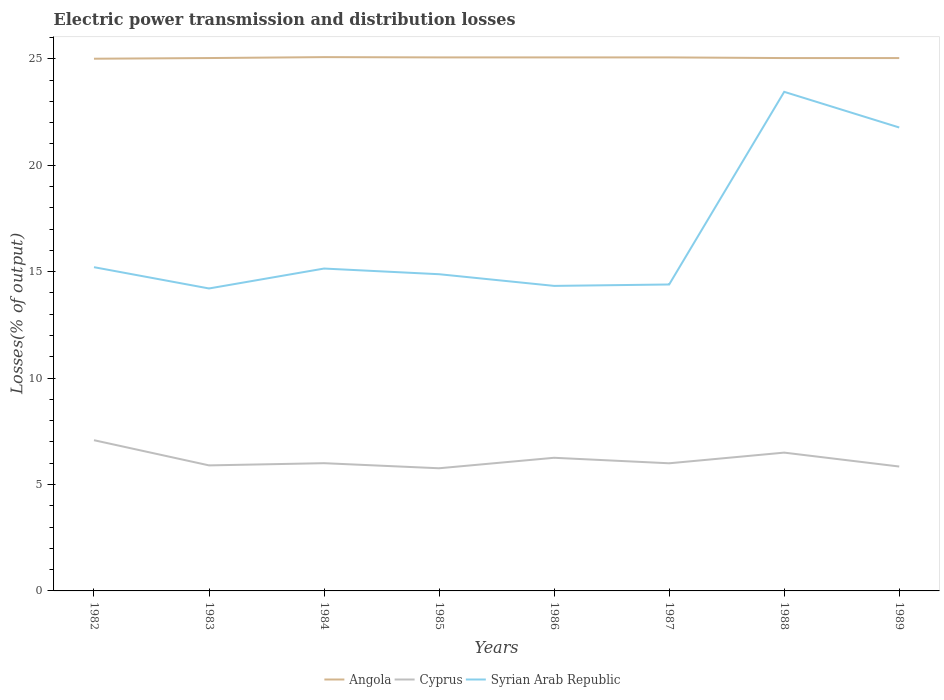How many different coloured lines are there?
Provide a short and direct response. 3. Across all years, what is the maximum electric power transmission and distribution losses in Cyprus?
Give a very brief answer. 5.76. In which year was the electric power transmission and distribution losses in Cyprus maximum?
Your answer should be very brief. 1985. What is the total electric power transmission and distribution losses in Cyprus in the graph?
Your answer should be very brief. -0.73. What is the difference between the highest and the second highest electric power transmission and distribution losses in Syrian Arab Republic?
Your response must be concise. 9.24. Is the electric power transmission and distribution losses in Syrian Arab Republic strictly greater than the electric power transmission and distribution losses in Angola over the years?
Keep it short and to the point. Yes. How many lines are there?
Ensure brevity in your answer.  3. How many years are there in the graph?
Offer a terse response. 8. What is the difference between two consecutive major ticks on the Y-axis?
Ensure brevity in your answer.  5. Are the values on the major ticks of Y-axis written in scientific E-notation?
Keep it short and to the point. No. Does the graph contain any zero values?
Your response must be concise. No. How many legend labels are there?
Make the answer very short. 3. What is the title of the graph?
Your answer should be very brief. Electric power transmission and distribution losses. What is the label or title of the X-axis?
Provide a succinct answer. Years. What is the label or title of the Y-axis?
Offer a very short reply. Losses(% of output). What is the Losses(% of output) in Cyprus in 1982?
Your answer should be compact. 7.08. What is the Losses(% of output) of Syrian Arab Republic in 1982?
Make the answer very short. 15.21. What is the Losses(% of output) of Angola in 1983?
Make the answer very short. 25.03. What is the Losses(% of output) of Cyprus in 1983?
Offer a terse response. 5.9. What is the Losses(% of output) in Syrian Arab Republic in 1983?
Offer a very short reply. 14.21. What is the Losses(% of output) of Angola in 1984?
Make the answer very short. 25.07. What is the Losses(% of output) in Syrian Arab Republic in 1984?
Your answer should be compact. 15.14. What is the Losses(% of output) of Angola in 1985?
Offer a very short reply. 25.06. What is the Losses(% of output) in Cyprus in 1985?
Offer a terse response. 5.76. What is the Losses(% of output) in Syrian Arab Republic in 1985?
Ensure brevity in your answer.  14.88. What is the Losses(% of output) of Angola in 1986?
Your answer should be very brief. 25.06. What is the Losses(% of output) of Cyprus in 1986?
Offer a terse response. 6.25. What is the Losses(% of output) in Syrian Arab Republic in 1986?
Your answer should be very brief. 14.33. What is the Losses(% of output) of Angola in 1987?
Give a very brief answer. 25.06. What is the Losses(% of output) in Cyprus in 1987?
Provide a short and direct response. 6. What is the Losses(% of output) in Syrian Arab Republic in 1987?
Ensure brevity in your answer.  14.39. What is the Losses(% of output) in Angola in 1988?
Keep it short and to the point. 25.03. What is the Losses(% of output) in Cyprus in 1988?
Make the answer very short. 6.5. What is the Losses(% of output) in Syrian Arab Republic in 1988?
Your answer should be compact. 23.44. What is the Losses(% of output) of Angola in 1989?
Provide a succinct answer. 25.03. What is the Losses(% of output) of Cyprus in 1989?
Provide a succinct answer. 5.84. What is the Losses(% of output) of Syrian Arab Republic in 1989?
Offer a very short reply. 21.77. Across all years, what is the maximum Losses(% of output) of Angola?
Provide a short and direct response. 25.07. Across all years, what is the maximum Losses(% of output) in Cyprus?
Ensure brevity in your answer.  7.08. Across all years, what is the maximum Losses(% of output) of Syrian Arab Republic?
Offer a very short reply. 23.44. Across all years, what is the minimum Losses(% of output) of Angola?
Offer a terse response. 25. Across all years, what is the minimum Losses(% of output) of Cyprus?
Your answer should be compact. 5.76. Across all years, what is the minimum Losses(% of output) of Syrian Arab Republic?
Ensure brevity in your answer.  14.21. What is the total Losses(% of output) in Angola in the graph?
Give a very brief answer. 200.35. What is the total Losses(% of output) in Cyprus in the graph?
Keep it short and to the point. 49.33. What is the total Losses(% of output) in Syrian Arab Republic in the graph?
Offer a very short reply. 133.37. What is the difference between the Losses(% of output) of Angola in 1982 and that in 1983?
Your answer should be very brief. -0.03. What is the difference between the Losses(% of output) of Cyprus in 1982 and that in 1983?
Make the answer very short. 1.18. What is the difference between the Losses(% of output) in Syrian Arab Republic in 1982 and that in 1983?
Provide a short and direct response. 1. What is the difference between the Losses(% of output) in Angola in 1982 and that in 1984?
Make the answer very short. -0.07. What is the difference between the Losses(% of output) in Cyprus in 1982 and that in 1984?
Ensure brevity in your answer.  1.08. What is the difference between the Losses(% of output) in Syrian Arab Republic in 1982 and that in 1984?
Provide a short and direct response. 0.06. What is the difference between the Losses(% of output) in Angola in 1982 and that in 1985?
Your answer should be compact. -0.06. What is the difference between the Losses(% of output) in Cyprus in 1982 and that in 1985?
Provide a short and direct response. 1.32. What is the difference between the Losses(% of output) in Syrian Arab Republic in 1982 and that in 1985?
Provide a succinct answer. 0.33. What is the difference between the Losses(% of output) of Angola in 1982 and that in 1986?
Give a very brief answer. -0.06. What is the difference between the Losses(% of output) of Cyprus in 1982 and that in 1986?
Your response must be concise. 0.83. What is the difference between the Losses(% of output) of Syrian Arab Republic in 1982 and that in 1986?
Offer a very short reply. 0.88. What is the difference between the Losses(% of output) of Angola in 1982 and that in 1987?
Provide a short and direct response. -0.06. What is the difference between the Losses(% of output) in Cyprus in 1982 and that in 1987?
Offer a terse response. 1.08. What is the difference between the Losses(% of output) in Syrian Arab Republic in 1982 and that in 1987?
Make the answer very short. 0.81. What is the difference between the Losses(% of output) in Angola in 1982 and that in 1988?
Your response must be concise. -0.03. What is the difference between the Losses(% of output) in Cyprus in 1982 and that in 1988?
Keep it short and to the point. 0.58. What is the difference between the Losses(% of output) in Syrian Arab Republic in 1982 and that in 1988?
Make the answer very short. -8.24. What is the difference between the Losses(% of output) of Angola in 1982 and that in 1989?
Provide a short and direct response. -0.03. What is the difference between the Losses(% of output) in Cyprus in 1982 and that in 1989?
Offer a very short reply. 1.24. What is the difference between the Losses(% of output) in Syrian Arab Republic in 1982 and that in 1989?
Make the answer very short. -6.56. What is the difference between the Losses(% of output) of Angola in 1983 and that in 1984?
Your answer should be very brief. -0.04. What is the difference between the Losses(% of output) in Cyprus in 1983 and that in 1984?
Provide a succinct answer. -0.1. What is the difference between the Losses(% of output) in Syrian Arab Republic in 1983 and that in 1984?
Offer a terse response. -0.94. What is the difference between the Losses(% of output) in Angola in 1983 and that in 1985?
Provide a succinct answer. -0.03. What is the difference between the Losses(% of output) in Cyprus in 1983 and that in 1985?
Provide a short and direct response. 0.13. What is the difference between the Losses(% of output) of Syrian Arab Republic in 1983 and that in 1985?
Ensure brevity in your answer.  -0.67. What is the difference between the Losses(% of output) of Angola in 1983 and that in 1986?
Give a very brief answer. -0.03. What is the difference between the Losses(% of output) of Cyprus in 1983 and that in 1986?
Offer a very short reply. -0.36. What is the difference between the Losses(% of output) of Syrian Arab Republic in 1983 and that in 1986?
Your response must be concise. -0.12. What is the difference between the Losses(% of output) in Angola in 1983 and that in 1987?
Offer a terse response. -0.03. What is the difference between the Losses(% of output) in Cyprus in 1983 and that in 1987?
Offer a very short reply. -0.1. What is the difference between the Losses(% of output) in Syrian Arab Republic in 1983 and that in 1987?
Keep it short and to the point. -0.19. What is the difference between the Losses(% of output) of Angola in 1983 and that in 1988?
Provide a short and direct response. 0. What is the difference between the Losses(% of output) in Cyprus in 1983 and that in 1988?
Provide a short and direct response. -0.6. What is the difference between the Losses(% of output) of Syrian Arab Republic in 1983 and that in 1988?
Your answer should be compact. -9.24. What is the difference between the Losses(% of output) in Angola in 1983 and that in 1989?
Provide a succinct answer. 0. What is the difference between the Losses(% of output) in Cyprus in 1983 and that in 1989?
Keep it short and to the point. 0.05. What is the difference between the Losses(% of output) of Syrian Arab Republic in 1983 and that in 1989?
Your response must be concise. -7.56. What is the difference between the Losses(% of output) of Angola in 1984 and that in 1985?
Provide a succinct answer. 0.01. What is the difference between the Losses(% of output) of Cyprus in 1984 and that in 1985?
Your answer should be compact. 0.24. What is the difference between the Losses(% of output) of Syrian Arab Republic in 1984 and that in 1985?
Give a very brief answer. 0.27. What is the difference between the Losses(% of output) of Angola in 1984 and that in 1986?
Your answer should be very brief. 0.01. What is the difference between the Losses(% of output) in Cyprus in 1984 and that in 1986?
Offer a terse response. -0.25. What is the difference between the Losses(% of output) in Syrian Arab Republic in 1984 and that in 1986?
Make the answer very short. 0.81. What is the difference between the Losses(% of output) in Angola in 1984 and that in 1987?
Provide a succinct answer. 0.01. What is the difference between the Losses(% of output) in Cyprus in 1984 and that in 1987?
Your answer should be compact. 0. What is the difference between the Losses(% of output) of Syrian Arab Republic in 1984 and that in 1987?
Your answer should be compact. 0.75. What is the difference between the Losses(% of output) in Angola in 1984 and that in 1988?
Give a very brief answer. 0.04. What is the difference between the Losses(% of output) of Cyprus in 1984 and that in 1988?
Keep it short and to the point. -0.5. What is the difference between the Losses(% of output) in Syrian Arab Republic in 1984 and that in 1988?
Your answer should be compact. -8.3. What is the difference between the Losses(% of output) of Angola in 1984 and that in 1989?
Provide a short and direct response. 0.04. What is the difference between the Losses(% of output) in Cyprus in 1984 and that in 1989?
Offer a terse response. 0.16. What is the difference between the Losses(% of output) of Syrian Arab Republic in 1984 and that in 1989?
Keep it short and to the point. -6.63. What is the difference between the Losses(% of output) in Cyprus in 1985 and that in 1986?
Your response must be concise. -0.49. What is the difference between the Losses(% of output) of Syrian Arab Republic in 1985 and that in 1986?
Your answer should be very brief. 0.55. What is the difference between the Losses(% of output) of Cyprus in 1985 and that in 1987?
Give a very brief answer. -0.23. What is the difference between the Losses(% of output) in Syrian Arab Republic in 1985 and that in 1987?
Your answer should be very brief. 0.48. What is the difference between the Losses(% of output) in Angola in 1985 and that in 1988?
Your response must be concise. 0.03. What is the difference between the Losses(% of output) of Cyprus in 1985 and that in 1988?
Ensure brevity in your answer.  -0.73. What is the difference between the Losses(% of output) in Syrian Arab Republic in 1985 and that in 1988?
Keep it short and to the point. -8.57. What is the difference between the Losses(% of output) in Angola in 1985 and that in 1989?
Your answer should be very brief. 0.03. What is the difference between the Losses(% of output) in Cyprus in 1985 and that in 1989?
Offer a terse response. -0.08. What is the difference between the Losses(% of output) in Syrian Arab Republic in 1985 and that in 1989?
Offer a terse response. -6.89. What is the difference between the Losses(% of output) of Cyprus in 1986 and that in 1987?
Offer a very short reply. 0.26. What is the difference between the Losses(% of output) of Syrian Arab Republic in 1986 and that in 1987?
Ensure brevity in your answer.  -0.07. What is the difference between the Losses(% of output) in Angola in 1986 and that in 1988?
Your answer should be compact. 0.03. What is the difference between the Losses(% of output) in Cyprus in 1986 and that in 1988?
Make the answer very short. -0.24. What is the difference between the Losses(% of output) in Syrian Arab Republic in 1986 and that in 1988?
Provide a succinct answer. -9.12. What is the difference between the Losses(% of output) in Angola in 1986 and that in 1989?
Make the answer very short. 0.03. What is the difference between the Losses(% of output) of Cyprus in 1986 and that in 1989?
Give a very brief answer. 0.41. What is the difference between the Losses(% of output) in Syrian Arab Republic in 1986 and that in 1989?
Ensure brevity in your answer.  -7.44. What is the difference between the Losses(% of output) in Angola in 1987 and that in 1988?
Ensure brevity in your answer.  0.03. What is the difference between the Losses(% of output) in Cyprus in 1987 and that in 1988?
Ensure brevity in your answer.  -0.5. What is the difference between the Losses(% of output) in Syrian Arab Republic in 1987 and that in 1988?
Keep it short and to the point. -9.05. What is the difference between the Losses(% of output) in Angola in 1987 and that in 1989?
Your answer should be very brief. 0.03. What is the difference between the Losses(% of output) of Cyprus in 1987 and that in 1989?
Offer a terse response. 0.15. What is the difference between the Losses(% of output) of Syrian Arab Republic in 1987 and that in 1989?
Make the answer very short. -7.37. What is the difference between the Losses(% of output) in Cyprus in 1988 and that in 1989?
Your answer should be very brief. 0.65. What is the difference between the Losses(% of output) of Syrian Arab Republic in 1988 and that in 1989?
Keep it short and to the point. 1.68. What is the difference between the Losses(% of output) in Angola in 1982 and the Losses(% of output) in Cyprus in 1983?
Provide a short and direct response. 19.1. What is the difference between the Losses(% of output) in Angola in 1982 and the Losses(% of output) in Syrian Arab Republic in 1983?
Give a very brief answer. 10.79. What is the difference between the Losses(% of output) of Cyprus in 1982 and the Losses(% of output) of Syrian Arab Republic in 1983?
Provide a short and direct response. -7.13. What is the difference between the Losses(% of output) of Angola in 1982 and the Losses(% of output) of Cyprus in 1984?
Your answer should be very brief. 19. What is the difference between the Losses(% of output) in Angola in 1982 and the Losses(% of output) in Syrian Arab Republic in 1984?
Provide a short and direct response. 9.86. What is the difference between the Losses(% of output) in Cyprus in 1982 and the Losses(% of output) in Syrian Arab Republic in 1984?
Offer a very short reply. -8.06. What is the difference between the Losses(% of output) in Angola in 1982 and the Losses(% of output) in Cyprus in 1985?
Make the answer very short. 19.24. What is the difference between the Losses(% of output) of Angola in 1982 and the Losses(% of output) of Syrian Arab Republic in 1985?
Offer a terse response. 10.12. What is the difference between the Losses(% of output) of Cyprus in 1982 and the Losses(% of output) of Syrian Arab Republic in 1985?
Give a very brief answer. -7.8. What is the difference between the Losses(% of output) of Angola in 1982 and the Losses(% of output) of Cyprus in 1986?
Your answer should be very brief. 18.75. What is the difference between the Losses(% of output) of Angola in 1982 and the Losses(% of output) of Syrian Arab Republic in 1986?
Your answer should be very brief. 10.67. What is the difference between the Losses(% of output) of Cyprus in 1982 and the Losses(% of output) of Syrian Arab Republic in 1986?
Make the answer very short. -7.25. What is the difference between the Losses(% of output) in Angola in 1982 and the Losses(% of output) in Cyprus in 1987?
Your answer should be very brief. 19. What is the difference between the Losses(% of output) of Angola in 1982 and the Losses(% of output) of Syrian Arab Republic in 1987?
Offer a terse response. 10.61. What is the difference between the Losses(% of output) in Cyprus in 1982 and the Losses(% of output) in Syrian Arab Republic in 1987?
Make the answer very short. -7.31. What is the difference between the Losses(% of output) in Angola in 1982 and the Losses(% of output) in Cyprus in 1988?
Provide a short and direct response. 18.5. What is the difference between the Losses(% of output) of Angola in 1982 and the Losses(% of output) of Syrian Arab Republic in 1988?
Make the answer very short. 1.55. What is the difference between the Losses(% of output) in Cyprus in 1982 and the Losses(% of output) in Syrian Arab Republic in 1988?
Your response must be concise. -16.36. What is the difference between the Losses(% of output) in Angola in 1982 and the Losses(% of output) in Cyprus in 1989?
Your answer should be compact. 19.16. What is the difference between the Losses(% of output) of Angola in 1982 and the Losses(% of output) of Syrian Arab Republic in 1989?
Provide a short and direct response. 3.23. What is the difference between the Losses(% of output) of Cyprus in 1982 and the Losses(% of output) of Syrian Arab Republic in 1989?
Offer a terse response. -14.69. What is the difference between the Losses(% of output) in Angola in 1983 and the Losses(% of output) in Cyprus in 1984?
Ensure brevity in your answer.  19.03. What is the difference between the Losses(% of output) in Angola in 1983 and the Losses(% of output) in Syrian Arab Republic in 1984?
Give a very brief answer. 9.89. What is the difference between the Losses(% of output) in Cyprus in 1983 and the Losses(% of output) in Syrian Arab Republic in 1984?
Keep it short and to the point. -9.25. What is the difference between the Losses(% of output) of Angola in 1983 and the Losses(% of output) of Cyprus in 1985?
Give a very brief answer. 19.27. What is the difference between the Losses(% of output) of Angola in 1983 and the Losses(% of output) of Syrian Arab Republic in 1985?
Your answer should be very brief. 10.15. What is the difference between the Losses(% of output) of Cyprus in 1983 and the Losses(% of output) of Syrian Arab Republic in 1985?
Give a very brief answer. -8.98. What is the difference between the Losses(% of output) of Angola in 1983 and the Losses(% of output) of Cyprus in 1986?
Provide a succinct answer. 18.78. What is the difference between the Losses(% of output) of Angola in 1983 and the Losses(% of output) of Syrian Arab Republic in 1986?
Your answer should be very brief. 10.7. What is the difference between the Losses(% of output) in Cyprus in 1983 and the Losses(% of output) in Syrian Arab Republic in 1986?
Your answer should be very brief. -8.43. What is the difference between the Losses(% of output) in Angola in 1983 and the Losses(% of output) in Cyprus in 1987?
Your answer should be compact. 19.04. What is the difference between the Losses(% of output) of Angola in 1983 and the Losses(% of output) of Syrian Arab Republic in 1987?
Your answer should be compact. 10.64. What is the difference between the Losses(% of output) in Cyprus in 1983 and the Losses(% of output) in Syrian Arab Republic in 1987?
Make the answer very short. -8.5. What is the difference between the Losses(% of output) in Angola in 1983 and the Losses(% of output) in Cyprus in 1988?
Give a very brief answer. 18.54. What is the difference between the Losses(% of output) of Angola in 1983 and the Losses(% of output) of Syrian Arab Republic in 1988?
Keep it short and to the point. 1.59. What is the difference between the Losses(% of output) of Cyprus in 1983 and the Losses(% of output) of Syrian Arab Republic in 1988?
Provide a short and direct response. -17.55. What is the difference between the Losses(% of output) of Angola in 1983 and the Losses(% of output) of Cyprus in 1989?
Offer a terse response. 19.19. What is the difference between the Losses(% of output) in Angola in 1983 and the Losses(% of output) in Syrian Arab Republic in 1989?
Your answer should be compact. 3.26. What is the difference between the Losses(% of output) of Cyprus in 1983 and the Losses(% of output) of Syrian Arab Republic in 1989?
Offer a very short reply. -15.87. What is the difference between the Losses(% of output) in Angola in 1984 and the Losses(% of output) in Cyprus in 1985?
Give a very brief answer. 19.31. What is the difference between the Losses(% of output) in Angola in 1984 and the Losses(% of output) in Syrian Arab Republic in 1985?
Provide a short and direct response. 10.2. What is the difference between the Losses(% of output) in Cyprus in 1984 and the Losses(% of output) in Syrian Arab Republic in 1985?
Your answer should be compact. -8.88. What is the difference between the Losses(% of output) in Angola in 1984 and the Losses(% of output) in Cyprus in 1986?
Your answer should be compact. 18.82. What is the difference between the Losses(% of output) of Angola in 1984 and the Losses(% of output) of Syrian Arab Republic in 1986?
Offer a very short reply. 10.75. What is the difference between the Losses(% of output) in Cyprus in 1984 and the Losses(% of output) in Syrian Arab Republic in 1986?
Make the answer very short. -8.33. What is the difference between the Losses(% of output) in Angola in 1984 and the Losses(% of output) in Cyprus in 1987?
Provide a succinct answer. 19.08. What is the difference between the Losses(% of output) in Angola in 1984 and the Losses(% of output) in Syrian Arab Republic in 1987?
Keep it short and to the point. 10.68. What is the difference between the Losses(% of output) of Cyprus in 1984 and the Losses(% of output) of Syrian Arab Republic in 1987?
Your answer should be very brief. -8.39. What is the difference between the Losses(% of output) of Angola in 1984 and the Losses(% of output) of Cyprus in 1988?
Offer a terse response. 18.58. What is the difference between the Losses(% of output) of Angola in 1984 and the Losses(% of output) of Syrian Arab Republic in 1988?
Your response must be concise. 1.63. What is the difference between the Losses(% of output) of Cyprus in 1984 and the Losses(% of output) of Syrian Arab Republic in 1988?
Your answer should be compact. -17.45. What is the difference between the Losses(% of output) of Angola in 1984 and the Losses(% of output) of Cyprus in 1989?
Offer a very short reply. 19.23. What is the difference between the Losses(% of output) in Angola in 1984 and the Losses(% of output) in Syrian Arab Republic in 1989?
Offer a terse response. 3.31. What is the difference between the Losses(% of output) of Cyprus in 1984 and the Losses(% of output) of Syrian Arab Republic in 1989?
Keep it short and to the point. -15.77. What is the difference between the Losses(% of output) in Angola in 1985 and the Losses(% of output) in Cyprus in 1986?
Your answer should be very brief. 18.81. What is the difference between the Losses(% of output) of Angola in 1985 and the Losses(% of output) of Syrian Arab Republic in 1986?
Give a very brief answer. 10.73. What is the difference between the Losses(% of output) of Cyprus in 1985 and the Losses(% of output) of Syrian Arab Republic in 1986?
Offer a very short reply. -8.57. What is the difference between the Losses(% of output) of Angola in 1985 and the Losses(% of output) of Cyprus in 1987?
Offer a very short reply. 19.07. What is the difference between the Losses(% of output) of Angola in 1985 and the Losses(% of output) of Syrian Arab Republic in 1987?
Keep it short and to the point. 10.67. What is the difference between the Losses(% of output) in Cyprus in 1985 and the Losses(% of output) in Syrian Arab Republic in 1987?
Provide a succinct answer. -8.63. What is the difference between the Losses(% of output) of Angola in 1985 and the Losses(% of output) of Cyprus in 1988?
Make the answer very short. 18.57. What is the difference between the Losses(% of output) of Angola in 1985 and the Losses(% of output) of Syrian Arab Republic in 1988?
Your response must be concise. 1.62. What is the difference between the Losses(% of output) in Cyprus in 1985 and the Losses(% of output) in Syrian Arab Republic in 1988?
Ensure brevity in your answer.  -17.68. What is the difference between the Losses(% of output) of Angola in 1985 and the Losses(% of output) of Cyprus in 1989?
Keep it short and to the point. 19.22. What is the difference between the Losses(% of output) in Angola in 1985 and the Losses(% of output) in Syrian Arab Republic in 1989?
Provide a succinct answer. 3.29. What is the difference between the Losses(% of output) in Cyprus in 1985 and the Losses(% of output) in Syrian Arab Republic in 1989?
Your response must be concise. -16.01. What is the difference between the Losses(% of output) in Angola in 1986 and the Losses(% of output) in Cyprus in 1987?
Your answer should be compact. 19.07. What is the difference between the Losses(% of output) of Angola in 1986 and the Losses(% of output) of Syrian Arab Republic in 1987?
Your answer should be very brief. 10.67. What is the difference between the Losses(% of output) in Cyprus in 1986 and the Losses(% of output) in Syrian Arab Republic in 1987?
Give a very brief answer. -8.14. What is the difference between the Losses(% of output) of Angola in 1986 and the Losses(% of output) of Cyprus in 1988?
Keep it short and to the point. 18.57. What is the difference between the Losses(% of output) of Angola in 1986 and the Losses(% of output) of Syrian Arab Republic in 1988?
Offer a terse response. 1.62. What is the difference between the Losses(% of output) of Cyprus in 1986 and the Losses(% of output) of Syrian Arab Republic in 1988?
Offer a very short reply. -17.19. What is the difference between the Losses(% of output) in Angola in 1986 and the Losses(% of output) in Cyprus in 1989?
Provide a succinct answer. 19.22. What is the difference between the Losses(% of output) in Angola in 1986 and the Losses(% of output) in Syrian Arab Republic in 1989?
Provide a short and direct response. 3.29. What is the difference between the Losses(% of output) in Cyprus in 1986 and the Losses(% of output) in Syrian Arab Republic in 1989?
Give a very brief answer. -15.52. What is the difference between the Losses(% of output) of Angola in 1987 and the Losses(% of output) of Cyprus in 1988?
Offer a terse response. 18.57. What is the difference between the Losses(% of output) in Angola in 1987 and the Losses(% of output) in Syrian Arab Republic in 1988?
Make the answer very short. 1.62. What is the difference between the Losses(% of output) of Cyprus in 1987 and the Losses(% of output) of Syrian Arab Republic in 1988?
Your response must be concise. -17.45. What is the difference between the Losses(% of output) of Angola in 1987 and the Losses(% of output) of Cyprus in 1989?
Your answer should be compact. 19.22. What is the difference between the Losses(% of output) in Angola in 1987 and the Losses(% of output) in Syrian Arab Republic in 1989?
Your answer should be very brief. 3.29. What is the difference between the Losses(% of output) in Cyprus in 1987 and the Losses(% of output) in Syrian Arab Republic in 1989?
Make the answer very short. -15.77. What is the difference between the Losses(% of output) of Angola in 1988 and the Losses(% of output) of Cyprus in 1989?
Your answer should be very brief. 19.19. What is the difference between the Losses(% of output) in Angola in 1988 and the Losses(% of output) in Syrian Arab Republic in 1989?
Provide a succinct answer. 3.26. What is the difference between the Losses(% of output) of Cyprus in 1988 and the Losses(% of output) of Syrian Arab Republic in 1989?
Keep it short and to the point. -15.27. What is the average Losses(% of output) of Angola per year?
Offer a very short reply. 25.04. What is the average Losses(% of output) in Cyprus per year?
Make the answer very short. 6.17. What is the average Losses(% of output) of Syrian Arab Republic per year?
Provide a short and direct response. 16.67. In the year 1982, what is the difference between the Losses(% of output) in Angola and Losses(% of output) in Cyprus?
Offer a terse response. 17.92. In the year 1982, what is the difference between the Losses(% of output) in Angola and Losses(% of output) in Syrian Arab Republic?
Offer a terse response. 9.79. In the year 1982, what is the difference between the Losses(% of output) in Cyprus and Losses(% of output) in Syrian Arab Republic?
Your answer should be very brief. -8.13. In the year 1983, what is the difference between the Losses(% of output) in Angola and Losses(% of output) in Cyprus?
Provide a short and direct response. 19.14. In the year 1983, what is the difference between the Losses(% of output) in Angola and Losses(% of output) in Syrian Arab Republic?
Your answer should be compact. 10.82. In the year 1983, what is the difference between the Losses(% of output) in Cyprus and Losses(% of output) in Syrian Arab Republic?
Keep it short and to the point. -8.31. In the year 1984, what is the difference between the Losses(% of output) in Angola and Losses(% of output) in Cyprus?
Your response must be concise. 19.07. In the year 1984, what is the difference between the Losses(% of output) of Angola and Losses(% of output) of Syrian Arab Republic?
Ensure brevity in your answer.  9.93. In the year 1984, what is the difference between the Losses(% of output) in Cyprus and Losses(% of output) in Syrian Arab Republic?
Ensure brevity in your answer.  -9.14. In the year 1985, what is the difference between the Losses(% of output) in Angola and Losses(% of output) in Cyprus?
Provide a short and direct response. 19.3. In the year 1985, what is the difference between the Losses(% of output) in Angola and Losses(% of output) in Syrian Arab Republic?
Keep it short and to the point. 10.18. In the year 1985, what is the difference between the Losses(% of output) in Cyprus and Losses(% of output) in Syrian Arab Republic?
Your answer should be very brief. -9.12. In the year 1986, what is the difference between the Losses(% of output) in Angola and Losses(% of output) in Cyprus?
Give a very brief answer. 18.81. In the year 1986, what is the difference between the Losses(% of output) in Angola and Losses(% of output) in Syrian Arab Republic?
Your answer should be compact. 10.73. In the year 1986, what is the difference between the Losses(% of output) of Cyprus and Losses(% of output) of Syrian Arab Republic?
Your answer should be compact. -8.07. In the year 1987, what is the difference between the Losses(% of output) of Angola and Losses(% of output) of Cyprus?
Your answer should be very brief. 19.07. In the year 1987, what is the difference between the Losses(% of output) in Angola and Losses(% of output) in Syrian Arab Republic?
Your response must be concise. 10.67. In the year 1987, what is the difference between the Losses(% of output) of Cyprus and Losses(% of output) of Syrian Arab Republic?
Your response must be concise. -8.4. In the year 1988, what is the difference between the Losses(% of output) in Angola and Losses(% of output) in Cyprus?
Your answer should be compact. 18.53. In the year 1988, what is the difference between the Losses(% of output) in Angola and Losses(% of output) in Syrian Arab Republic?
Give a very brief answer. 1.59. In the year 1988, what is the difference between the Losses(% of output) of Cyprus and Losses(% of output) of Syrian Arab Republic?
Offer a very short reply. -16.95. In the year 1989, what is the difference between the Losses(% of output) in Angola and Losses(% of output) in Cyprus?
Ensure brevity in your answer.  19.19. In the year 1989, what is the difference between the Losses(% of output) in Angola and Losses(% of output) in Syrian Arab Republic?
Provide a succinct answer. 3.26. In the year 1989, what is the difference between the Losses(% of output) in Cyprus and Losses(% of output) in Syrian Arab Republic?
Your response must be concise. -15.93. What is the ratio of the Losses(% of output) in Angola in 1982 to that in 1983?
Make the answer very short. 1. What is the ratio of the Losses(% of output) of Cyprus in 1982 to that in 1983?
Give a very brief answer. 1.2. What is the ratio of the Losses(% of output) in Syrian Arab Republic in 1982 to that in 1983?
Keep it short and to the point. 1.07. What is the ratio of the Losses(% of output) in Angola in 1982 to that in 1984?
Ensure brevity in your answer.  1. What is the ratio of the Losses(% of output) in Cyprus in 1982 to that in 1984?
Keep it short and to the point. 1.18. What is the ratio of the Losses(% of output) of Cyprus in 1982 to that in 1985?
Provide a succinct answer. 1.23. What is the ratio of the Losses(% of output) in Syrian Arab Republic in 1982 to that in 1985?
Your answer should be very brief. 1.02. What is the ratio of the Losses(% of output) in Angola in 1982 to that in 1986?
Provide a short and direct response. 1. What is the ratio of the Losses(% of output) of Cyprus in 1982 to that in 1986?
Your answer should be very brief. 1.13. What is the ratio of the Losses(% of output) in Syrian Arab Republic in 1982 to that in 1986?
Provide a succinct answer. 1.06. What is the ratio of the Losses(% of output) in Angola in 1982 to that in 1987?
Ensure brevity in your answer.  1. What is the ratio of the Losses(% of output) in Cyprus in 1982 to that in 1987?
Ensure brevity in your answer.  1.18. What is the ratio of the Losses(% of output) in Syrian Arab Republic in 1982 to that in 1987?
Make the answer very short. 1.06. What is the ratio of the Losses(% of output) in Angola in 1982 to that in 1988?
Your answer should be compact. 1. What is the ratio of the Losses(% of output) in Cyprus in 1982 to that in 1988?
Offer a terse response. 1.09. What is the ratio of the Losses(% of output) in Syrian Arab Republic in 1982 to that in 1988?
Your answer should be very brief. 0.65. What is the ratio of the Losses(% of output) in Angola in 1982 to that in 1989?
Offer a terse response. 1. What is the ratio of the Losses(% of output) in Cyprus in 1982 to that in 1989?
Provide a short and direct response. 1.21. What is the ratio of the Losses(% of output) in Syrian Arab Republic in 1982 to that in 1989?
Ensure brevity in your answer.  0.7. What is the ratio of the Losses(% of output) of Angola in 1983 to that in 1984?
Give a very brief answer. 1. What is the ratio of the Losses(% of output) of Cyprus in 1983 to that in 1984?
Keep it short and to the point. 0.98. What is the ratio of the Losses(% of output) in Syrian Arab Republic in 1983 to that in 1984?
Make the answer very short. 0.94. What is the ratio of the Losses(% of output) of Angola in 1983 to that in 1985?
Give a very brief answer. 1. What is the ratio of the Losses(% of output) of Cyprus in 1983 to that in 1985?
Provide a succinct answer. 1.02. What is the ratio of the Losses(% of output) in Syrian Arab Republic in 1983 to that in 1985?
Ensure brevity in your answer.  0.95. What is the ratio of the Losses(% of output) of Angola in 1983 to that in 1986?
Keep it short and to the point. 1. What is the ratio of the Losses(% of output) in Cyprus in 1983 to that in 1986?
Provide a succinct answer. 0.94. What is the ratio of the Losses(% of output) in Syrian Arab Republic in 1983 to that in 1986?
Make the answer very short. 0.99. What is the ratio of the Losses(% of output) in Angola in 1983 to that in 1987?
Provide a short and direct response. 1. What is the ratio of the Losses(% of output) in Cyprus in 1983 to that in 1987?
Offer a very short reply. 0.98. What is the ratio of the Losses(% of output) in Cyprus in 1983 to that in 1988?
Provide a short and direct response. 0.91. What is the ratio of the Losses(% of output) in Syrian Arab Republic in 1983 to that in 1988?
Make the answer very short. 0.61. What is the ratio of the Losses(% of output) of Cyprus in 1983 to that in 1989?
Ensure brevity in your answer.  1.01. What is the ratio of the Losses(% of output) in Syrian Arab Republic in 1983 to that in 1989?
Your answer should be compact. 0.65. What is the ratio of the Losses(% of output) of Angola in 1984 to that in 1985?
Provide a short and direct response. 1. What is the ratio of the Losses(% of output) of Cyprus in 1984 to that in 1985?
Make the answer very short. 1.04. What is the ratio of the Losses(% of output) in Syrian Arab Republic in 1984 to that in 1985?
Give a very brief answer. 1.02. What is the ratio of the Losses(% of output) of Angola in 1984 to that in 1986?
Give a very brief answer. 1. What is the ratio of the Losses(% of output) in Cyprus in 1984 to that in 1986?
Your answer should be very brief. 0.96. What is the ratio of the Losses(% of output) of Syrian Arab Republic in 1984 to that in 1986?
Make the answer very short. 1.06. What is the ratio of the Losses(% of output) of Syrian Arab Republic in 1984 to that in 1987?
Offer a terse response. 1.05. What is the ratio of the Losses(% of output) in Angola in 1984 to that in 1988?
Keep it short and to the point. 1. What is the ratio of the Losses(% of output) in Cyprus in 1984 to that in 1988?
Your answer should be compact. 0.92. What is the ratio of the Losses(% of output) of Syrian Arab Republic in 1984 to that in 1988?
Ensure brevity in your answer.  0.65. What is the ratio of the Losses(% of output) in Cyprus in 1984 to that in 1989?
Make the answer very short. 1.03. What is the ratio of the Losses(% of output) of Syrian Arab Republic in 1984 to that in 1989?
Offer a terse response. 0.7. What is the ratio of the Losses(% of output) of Angola in 1985 to that in 1986?
Make the answer very short. 1. What is the ratio of the Losses(% of output) of Cyprus in 1985 to that in 1986?
Ensure brevity in your answer.  0.92. What is the ratio of the Losses(% of output) in Syrian Arab Republic in 1985 to that in 1986?
Your answer should be very brief. 1.04. What is the ratio of the Losses(% of output) of Syrian Arab Republic in 1985 to that in 1987?
Offer a very short reply. 1.03. What is the ratio of the Losses(% of output) in Angola in 1985 to that in 1988?
Offer a very short reply. 1. What is the ratio of the Losses(% of output) in Cyprus in 1985 to that in 1988?
Your answer should be very brief. 0.89. What is the ratio of the Losses(% of output) in Syrian Arab Republic in 1985 to that in 1988?
Offer a terse response. 0.63. What is the ratio of the Losses(% of output) in Syrian Arab Republic in 1985 to that in 1989?
Provide a succinct answer. 0.68. What is the ratio of the Losses(% of output) in Angola in 1986 to that in 1987?
Your answer should be very brief. 1. What is the ratio of the Losses(% of output) of Cyprus in 1986 to that in 1987?
Your response must be concise. 1.04. What is the ratio of the Losses(% of output) in Syrian Arab Republic in 1986 to that in 1987?
Your answer should be very brief. 1. What is the ratio of the Losses(% of output) in Cyprus in 1986 to that in 1988?
Offer a terse response. 0.96. What is the ratio of the Losses(% of output) of Syrian Arab Republic in 1986 to that in 1988?
Your answer should be compact. 0.61. What is the ratio of the Losses(% of output) of Angola in 1986 to that in 1989?
Your response must be concise. 1. What is the ratio of the Losses(% of output) in Cyprus in 1986 to that in 1989?
Your answer should be very brief. 1.07. What is the ratio of the Losses(% of output) of Syrian Arab Republic in 1986 to that in 1989?
Offer a very short reply. 0.66. What is the ratio of the Losses(% of output) in Cyprus in 1987 to that in 1988?
Provide a short and direct response. 0.92. What is the ratio of the Losses(% of output) of Syrian Arab Republic in 1987 to that in 1988?
Your answer should be very brief. 0.61. What is the ratio of the Losses(% of output) of Syrian Arab Republic in 1987 to that in 1989?
Your answer should be very brief. 0.66. What is the ratio of the Losses(% of output) in Cyprus in 1988 to that in 1989?
Your response must be concise. 1.11. What is the ratio of the Losses(% of output) of Syrian Arab Republic in 1988 to that in 1989?
Make the answer very short. 1.08. What is the difference between the highest and the second highest Losses(% of output) of Angola?
Keep it short and to the point. 0.01. What is the difference between the highest and the second highest Losses(% of output) in Cyprus?
Give a very brief answer. 0.58. What is the difference between the highest and the second highest Losses(% of output) in Syrian Arab Republic?
Your response must be concise. 1.68. What is the difference between the highest and the lowest Losses(% of output) in Angola?
Provide a short and direct response. 0.07. What is the difference between the highest and the lowest Losses(% of output) in Cyprus?
Your answer should be very brief. 1.32. What is the difference between the highest and the lowest Losses(% of output) in Syrian Arab Republic?
Your answer should be very brief. 9.24. 